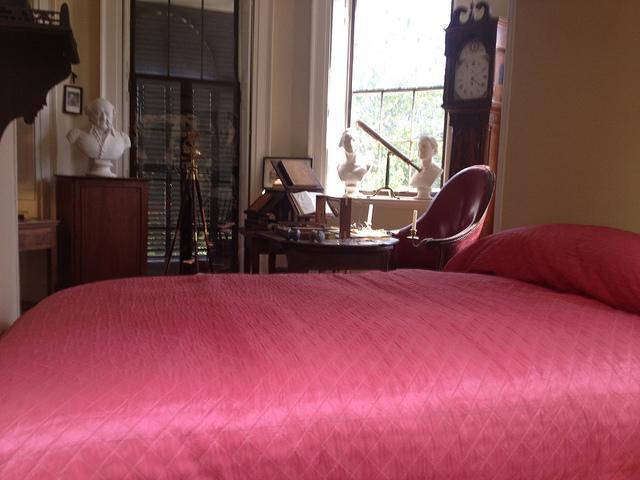How many chairs are in the photo?
Give a very brief answer. 1. How many horses are there?
Give a very brief answer. 0. 